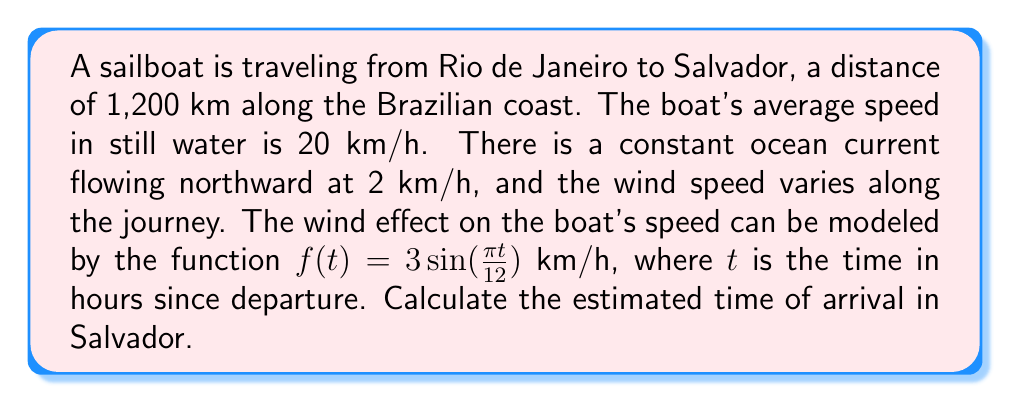Provide a solution to this math problem. To solve this problem, we need to consider the combined effects of the boat's speed, ocean current, and wind on the total distance traveled. Let's break it down step by step:

1) The boat's velocity is affected by three components:
   - Base speed: 20 km/h
   - Ocean current: 2 km/h (northward, which is favorable)
   - Wind effect: $f(t) = 3 \sin(\frac{\pi t}{12})$ km/h

2) The total velocity at any time $t$ is:
   $$v(t) = 20 + 2 + 3 \sin(\frac{\pi t}{12})$$

3) To find the time of arrival, we need to solve the equation:
   $$\int_0^T v(t) dt = 1200$$
   where $T$ is the time we're solving for.

4) Let's expand the integral:
   $$\int_0^T (22 + 3 \sin(\frac{\pi t}{12})) dt = 1200$$

5) Solving the integral:
   $$[22t - \frac{36}{\pi} \cos(\frac{\pi t}{12})]_0^T = 1200$$

6) Evaluating the bounds:
   $$(22T - \frac{36}{\pi} \cos(\frac{\pi T}{12})) - (0 - \frac{36}{\pi}) = 1200$$

7) Simplifying:
   $$22T - \frac{36}{\pi} \cos(\frac{\pi T}{12}) + \frac{36}{\pi} = 1200$$

8) This equation cannot be solved analytically. We need to use numerical methods, such as Newton's method, to find T.

9) Using a numerical solver, we find that $T \approx 52.8$ hours.
Answer: The estimated time of arrival in Salvador is approximately 52.8 hours after departure from Rio de Janeiro. 